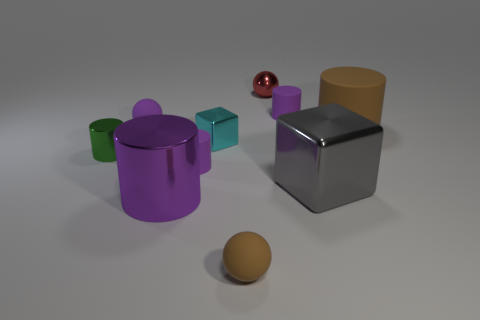What size is the sphere that is behind the small purple matte cylinder behind the tiny purple rubber object in front of the tiny green cylinder?
Keep it short and to the point. Small. Is the green cylinder the same size as the cyan object?
Ensure brevity in your answer.  Yes. How many objects are either big blue matte cubes or small purple matte cylinders?
Provide a short and direct response. 2. How big is the rubber sphere that is on the right side of the small purple matte cylinder in front of the purple rubber ball?
Make the answer very short. Small. The purple metallic thing has what size?
Your answer should be compact. Large. There is a small rubber thing that is both in front of the green thing and on the right side of the small cyan metallic thing; what shape is it?
Offer a very short reply. Sphere. The big metallic object that is the same shape as the big rubber thing is what color?
Ensure brevity in your answer.  Purple. What number of objects are either blocks in front of the tiny green shiny cylinder or metallic blocks that are in front of the green cylinder?
Your answer should be compact. 1. What is the shape of the big purple object?
Your answer should be compact. Cylinder. What shape is the small matte thing that is the same color as the big rubber thing?
Your response must be concise. Sphere. 